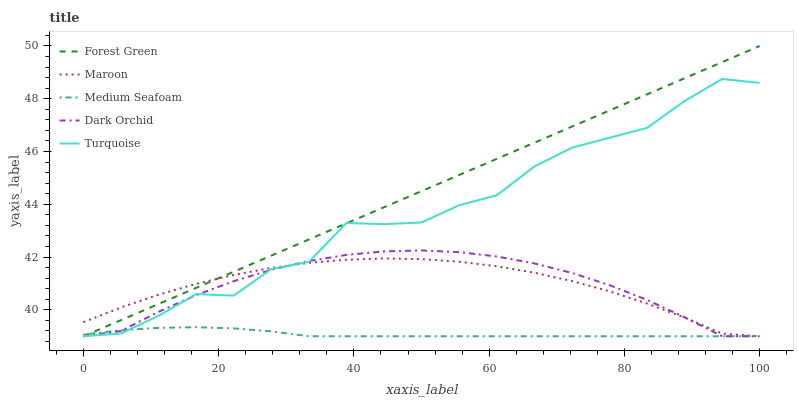Does Medium Seafoam have the minimum area under the curve?
Answer yes or no. Yes. Does Forest Green have the maximum area under the curve?
Answer yes or no. Yes. Does Turquoise have the minimum area under the curve?
Answer yes or no. No. Does Turquoise have the maximum area under the curve?
Answer yes or no. No. Is Forest Green the smoothest?
Answer yes or no. Yes. Is Turquoise the roughest?
Answer yes or no. Yes. Is Turquoise the smoothest?
Answer yes or no. No. Is Forest Green the roughest?
Answer yes or no. No. Does Dark Orchid have the lowest value?
Answer yes or no. Yes. Does Forest Green have the highest value?
Answer yes or no. Yes. Does Turquoise have the highest value?
Answer yes or no. No. Does Dark Orchid intersect Medium Seafoam?
Answer yes or no. Yes. Is Dark Orchid less than Medium Seafoam?
Answer yes or no. No. Is Dark Orchid greater than Medium Seafoam?
Answer yes or no. No. 